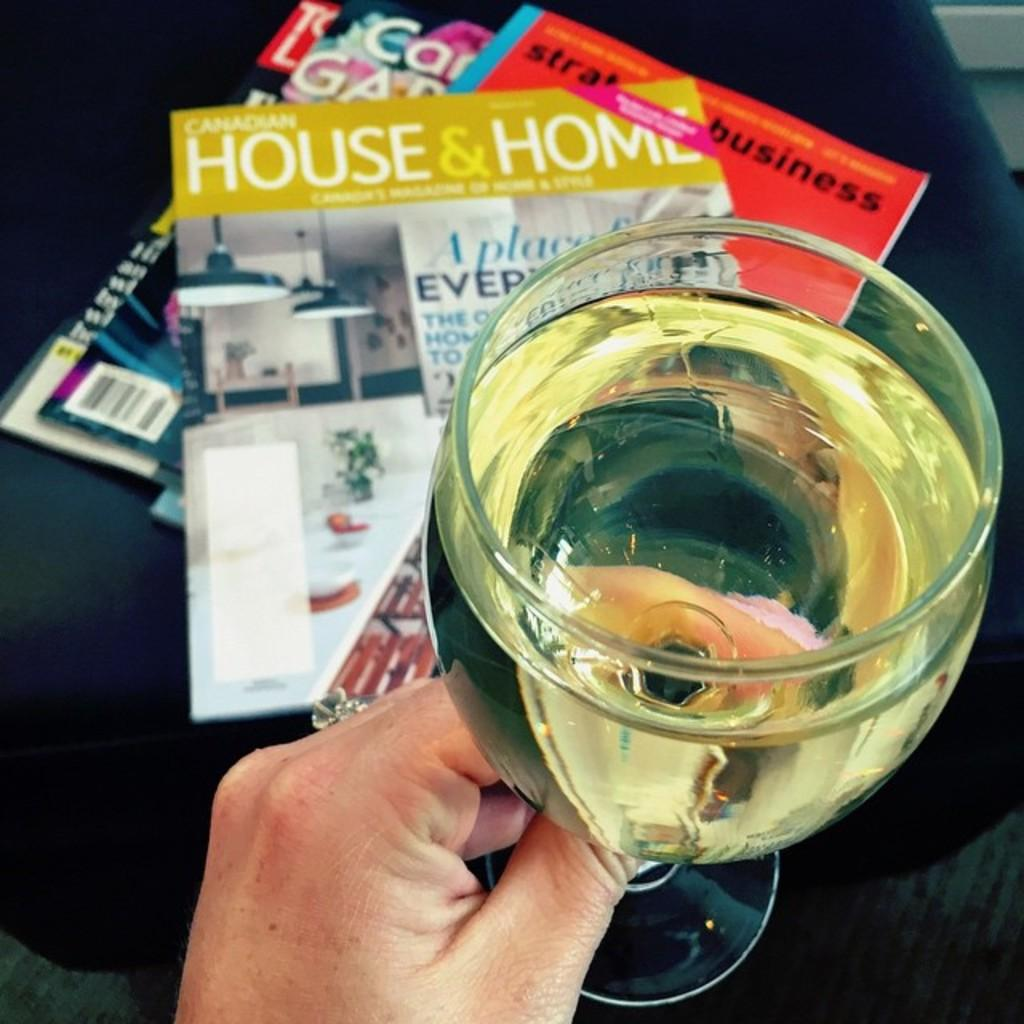Provide a one-sentence caption for the provided image. Someone is holding onto a glass of liquor with a HOUSE & HOME magazine (and others) in the background. 